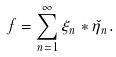Convert formula to latex. <formula><loc_0><loc_0><loc_500><loc_500>f = \sum _ { n = 1 } ^ { \infty } \xi _ { n } \ast \check { \eta } _ { n } .</formula> 